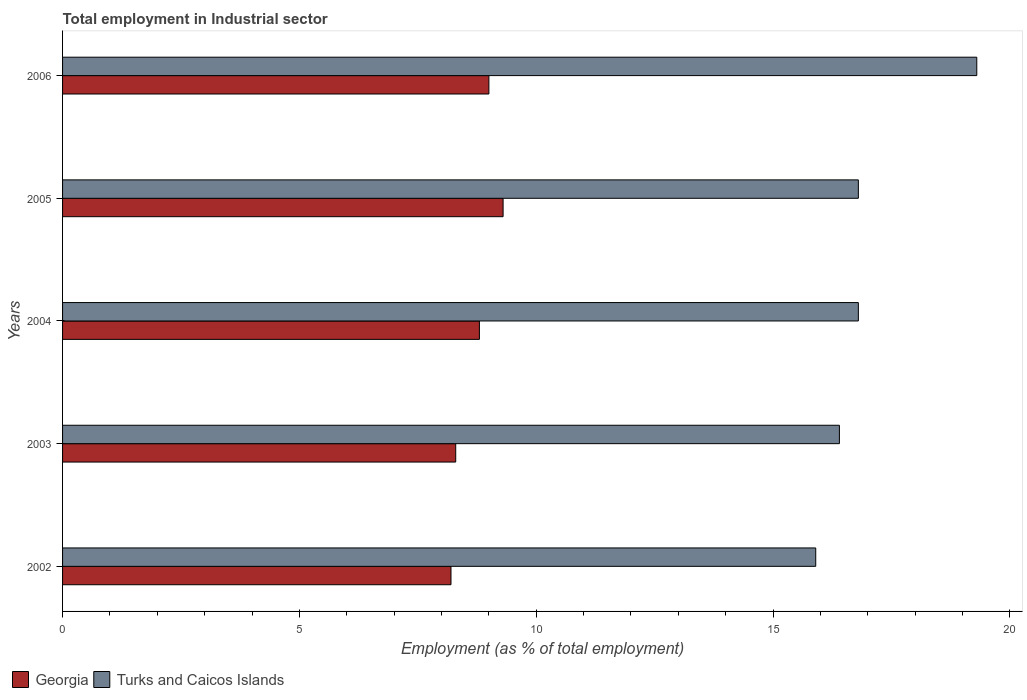How many different coloured bars are there?
Offer a terse response. 2. How many groups of bars are there?
Provide a succinct answer. 5. Are the number of bars per tick equal to the number of legend labels?
Ensure brevity in your answer.  Yes. How many bars are there on the 3rd tick from the top?
Your response must be concise. 2. What is the label of the 4th group of bars from the top?
Keep it short and to the point. 2003. In how many cases, is the number of bars for a given year not equal to the number of legend labels?
Ensure brevity in your answer.  0. What is the employment in industrial sector in Georgia in 2003?
Ensure brevity in your answer.  8.3. Across all years, what is the maximum employment in industrial sector in Georgia?
Keep it short and to the point. 9.3. Across all years, what is the minimum employment in industrial sector in Georgia?
Provide a succinct answer. 8.2. In which year was the employment in industrial sector in Turks and Caicos Islands minimum?
Offer a terse response. 2002. What is the total employment in industrial sector in Turks and Caicos Islands in the graph?
Keep it short and to the point. 85.2. What is the difference between the employment in industrial sector in Georgia in 2004 and that in 2006?
Provide a succinct answer. -0.2. What is the difference between the employment in industrial sector in Turks and Caicos Islands in 2005 and the employment in industrial sector in Georgia in 2003?
Provide a succinct answer. 8.5. What is the average employment in industrial sector in Turks and Caicos Islands per year?
Make the answer very short. 17.04. In the year 2002, what is the difference between the employment in industrial sector in Turks and Caicos Islands and employment in industrial sector in Georgia?
Offer a very short reply. 7.7. In how many years, is the employment in industrial sector in Georgia greater than 11 %?
Provide a succinct answer. 0. What is the ratio of the employment in industrial sector in Turks and Caicos Islands in 2004 to that in 2006?
Your response must be concise. 0.87. Is the difference between the employment in industrial sector in Turks and Caicos Islands in 2002 and 2006 greater than the difference between the employment in industrial sector in Georgia in 2002 and 2006?
Provide a short and direct response. No. What is the difference between the highest and the second highest employment in industrial sector in Georgia?
Provide a short and direct response. 0.3. What is the difference between the highest and the lowest employment in industrial sector in Turks and Caicos Islands?
Your answer should be compact. 3.4. In how many years, is the employment in industrial sector in Georgia greater than the average employment in industrial sector in Georgia taken over all years?
Make the answer very short. 3. Is the sum of the employment in industrial sector in Turks and Caicos Islands in 2004 and 2005 greater than the maximum employment in industrial sector in Georgia across all years?
Provide a short and direct response. Yes. What does the 1st bar from the top in 2003 represents?
Your answer should be compact. Turks and Caicos Islands. What does the 2nd bar from the bottom in 2005 represents?
Provide a short and direct response. Turks and Caicos Islands. How many years are there in the graph?
Make the answer very short. 5. What is the difference between two consecutive major ticks on the X-axis?
Your answer should be very brief. 5. Where does the legend appear in the graph?
Ensure brevity in your answer.  Bottom left. How many legend labels are there?
Ensure brevity in your answer.  2. How are the legend labels stacked?
Your answer should be compact. Horizontal. What is the title of the graph?
Your response must be concise. Total employment in Industrial sector. Does "European Union" appear as one of the legend labels in the graph?
Make the answer very short. No. What is the label or title of the X-axis?
Provide a short and direct response. Employment (as % of total employment). What is the Employment (as % of total employment) in Georgia in 2002?
Offer a terse response. 8.2. What is the Employment (as % of total employment) of Turks and Caicos Islands in 2002?
Make the answer very short. 15.9. What is the Employment (as % of total employment) in Georgia in 2003?
Your answer should be compact. 8.3. What is the Employment (as % of total employment) in Turks and Caicos Islands in 2003?
Offer a very short reply. 16.4. What is the Employment (as % of total employment) in Georgia in 2004?
Make the answer very short. 8.8. What is the Employment (as % of total employment) of Turks and Caicos Islands in 2004?
Your answer should be very brief. 16.8. What is the Employment (as % of total employment) of Georgia in 2005?
Offer a terse response. 9.3. What is the Employment (as % of total employment) of Turks and Caicos Islands in 2005?
Provide a short and direct response. 16.8. What is the Employment (as % of total employment) in Turks and Caicos Islands in 2006?
Offer a very short reply. 19.3. Across all years, what is the maximum Employment (as % of total employment) in Georgia?
Make the answer very short. 9.3. Across all years, what is the maximum Employment (as % of total employment) in Turks and Caicos Islands?
Your answer should be very brief. 19.3. Across all years, what is the minimum Employment (as % of total employment) of Georgia?
Offer a terse response. 8.2. Across all years, what is the minimum Employment (as % of total employment) in Turks and Caicos Islands?
Give a very brief answer. 15.9. What is the total Employment (as % of total employment) of Georgia in the graph?
Offer a terse response. 43.6. What is the total Employment (as % of total employment) in Turks and Caicos Islands in the graph?
Your response must be concise. 85.2. What is the difference between the Employment (as % of total employment) of Turks and Caicos Islands in 2002 and that in 2003?
Provide a succinct answer. -0.5. What is the difference between the Employment (as % of total employment) in Georgia in 2002 and that in 2004?
Your answer should be compact. -0.6. What is the difference between the Employment (as % of total employment) in Georgia in 2002 and that in 2005?
Provide a succinct answer. -1.1. What is the difference between the Employment (as % of total employment) of Turks and Caicos Islands in 2002 and that in 2005?
Offer a very short reply. -0.9. What is the difference between the Employment (as % of total employment) in Turks and Caicos Islands in 2002 and that in 2006?
Provide a succinct answer. -3.4. What is the difference between the Employment (as % of total employment) of Georgia in 2003 and that in 2005?
Offer a very short reply. -1. What is the difference between the Employment (as % of total employment) in Turks and Caicos Islands in 2003 and that in 2005?
Make the answer very short. -0.4. What is the difference between the Employment (as % of total employment) in Georgia in 2003 and that in 2006?
Your answer should be compact. -0.7. What is the difference between the Employment (as % of total employment) of Georgia in 2004 and that in 2005?
Your answer should be compact. -0.5. What is the difference between the Employment (as % of total employment) of Turks and Caicos Islands in 2004 and that in 2005?
Make the answer very short. 0. What is the difference between the Employment (as % of total employment) of Georgia in 2004 and that in 2006?
Offer a very short reply. -0.2. What is the difference between the Employment (as % of total employment) of Georgia in 2002 and the Employment (as % of total employment) of Turks and Caicos Islands in 2006?
Provide a succinct answer. -11.1. What is the difference between the Employment (as % of total employment) of Georgia in 2004 and the Employment (as % of total employment) of Turks and Caicos Islands in 2005?
Give a very brief answer. -8. What is the difference between the Employment (as % of total employment) of Georgia in 2004 and the Employment (as % of total employment) of Turks and Caicos Islands in 2006?
Provide a succinct answer. -10.5. What is the difference between the Employment (as % of total employment) of Georgia in 2005 and the Employment (as % of total employment) of Turks and Caicos Islands in 2006?
Provide a short and direct response. -10. What is the average Employment (as % of total employment) of Georgia per year?
Keep it short and to the point. 8.72. What is the average Employment (as % of total employment) of Turks and Caicos Islands per year?
Provide a short and direct response. 17.04. In the year 2002, what is the difference between the Employment (as % of total employment) in Georgia and Employment (as % of total employment) in Turks and Caicos Islands?
Offer a very short reply. -7.7. In the year 2003, what is the difference between the Employment (as % of total employment) of Georgia and Employment (as % of total employment) of Turks and Caicos Islands?
Provide a short and direct response. -8.1. In the year 2004, what is the difference between the Employment (as % of total employment) of Georgia and Employment (as % of total employment) of Turks and Caicos Islands?
Ensure brevity in your answer.  -8. In the year 2005, what is the difference between the Employment (as % of total employment) in Georgia and Employment (as % of total employment) in Turks and Caicos Islands?
Offer a very short reply. -7.5. In the year 2006, what is the difference between the Employment (as % of total employment) in Georgia and Employment (as % of total employment) in Turks and Caicos Islands?
Offer a terse response. -10.3. What is the ratio of the Employment (as % of total employment) in Georgia in 2002 to that in 2003?
Offer a terse response. 0.99. What is the ratio of the Employment (as % of total employment) in Turks and Caicos Islands in 2002 to that in 2003?
Your response must be concise. 0.97. What is the ratio of the Employment (as % of total employment) of Georgia in 2002 to that in 2004?
Keep it short and to the point. 0.93. What is the ratio of the Employment (as % of total employment) in Turks and Caicos Islands in 2002 to that in 2004?
Make the answer very short. 0.95. What is the ratio of the Employment (as % of total employment) in Georgia in 2002 to that in 2005?
Your answer should be compact. 0.88. What is the ratio of the Employment (as % of total employment) in Turks and Caicos Islands in 2002 to that in 2005?
Your answer should be very brief. 0.95. What is the ratio of the Employment (as % of total employment) of Georgia in 2002 to that in 2006?
Your answer should be compact. 0.91. What is the ratio of the Employment (as % of total employment) in Turks and Caicos Islands in 2002 to that in 2006?
Your response must be concise. 0.82. What is the ratio of the Employment (as % of total employment) in Georgia in 2003 to that in 2004?
Your answer should be very brief. 0.94. What is the ratio of the Employment (as % of total employment) in Turks and Caicos Islands in 2003 to that in 2004?
Offer a very short reply. 0.98. What is the ratio of the Employment (as % of total employment) in Georgia in 2003 to that in 2005?
Your answer should be compact. 0.89. What is the ratio of the Employment (as % of total employment) of Turks and Caicos Islands in 2003 to that in 2005?
Keep it short and to the point. 0.98. What is the ratio of the Employment (as % of total employment) in Georgia in 2003 to that in 2006?
Your answer should be very brief. 0.92. What is the ratio of the Employment (as % of total employment) in Turks and Caicos Islands in 2003 to that in 2006?
Give a very brief answer. 0.85. What is the ratio of the Employment (as % of total employment) in Georgia in 2004 to that in 2005?
Give a very brief answer. 0.95. What is the ratio of the Employment (as % of total employment) of Georgia in 2004 to that in 2006?
Keep it short and to the point. 0.98. What is the ratio of the Employment (as % of total employment) in Turks and Caicos Islands in 2004 to that in 2006?
Offer a terse response. 0.87. What is the ratio of the Employment (as % of total employment) in Georgia in 2005 to that in 2006?
Provide a succinct answer. 1.03. What is the ratio of the Employment (as % of total employment) in Turks and Caicos Islands in 2005 to that in 2006?
Provide a succinct answer. 0.87. 